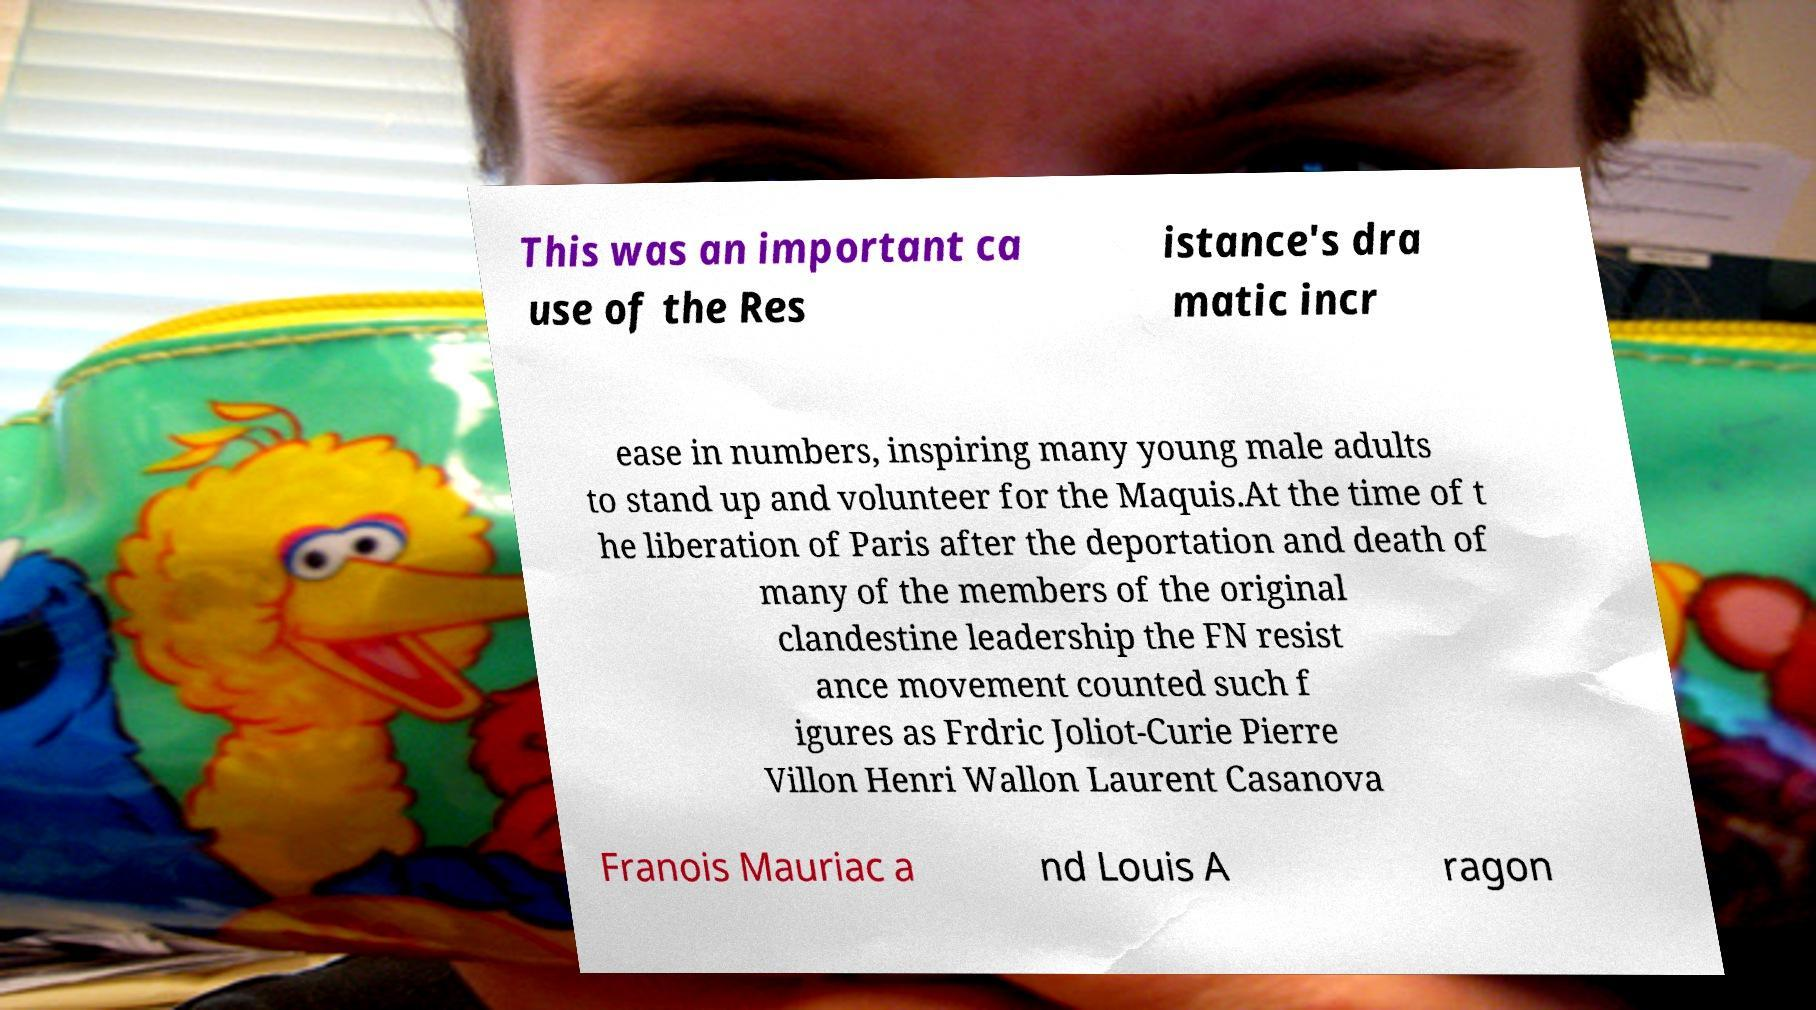Could you extract and type out the text from this image? This was an important ca use of the Res istance's dra matic incr ease in numbers, inspiring many young male adults to stand up and volunteer for the Maquis.At the time of t he liberation of Paris after the deportation and death of many of the members of the original clandestine leadership the FN resist ance movement counted such f igures as Frdric Joliot-Curie Pierre Villon Henri Wallon Laurent Casanova Franois Mauriac a nd Louis A ragon 